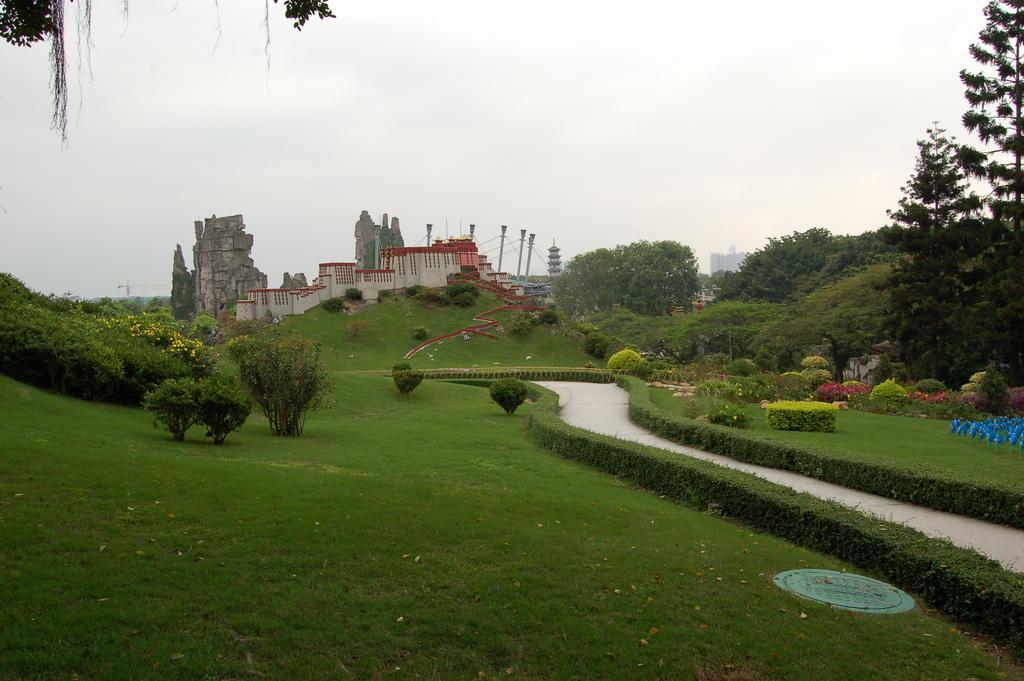Describe this image in one or two sentences. In this image there are buildings. At the bottom there are plants and we can see hedges. On the right there is a walkway. In the background there are trees and sky. We can see bushes. 